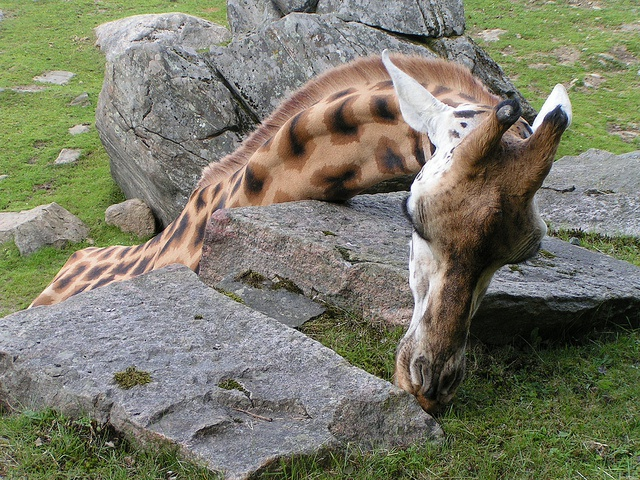Describe the objects in this image and their specific colors. I can see a giraffe in olive, black, gray, lightgray, and tan tones in this image. 